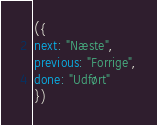Convert code to text. <code><loc_0><loc_0><loc_500><loc_500><_JavaScript_>({
next: "Næste",
previous: "Forrige",
done: "Udført"
})
</code> 